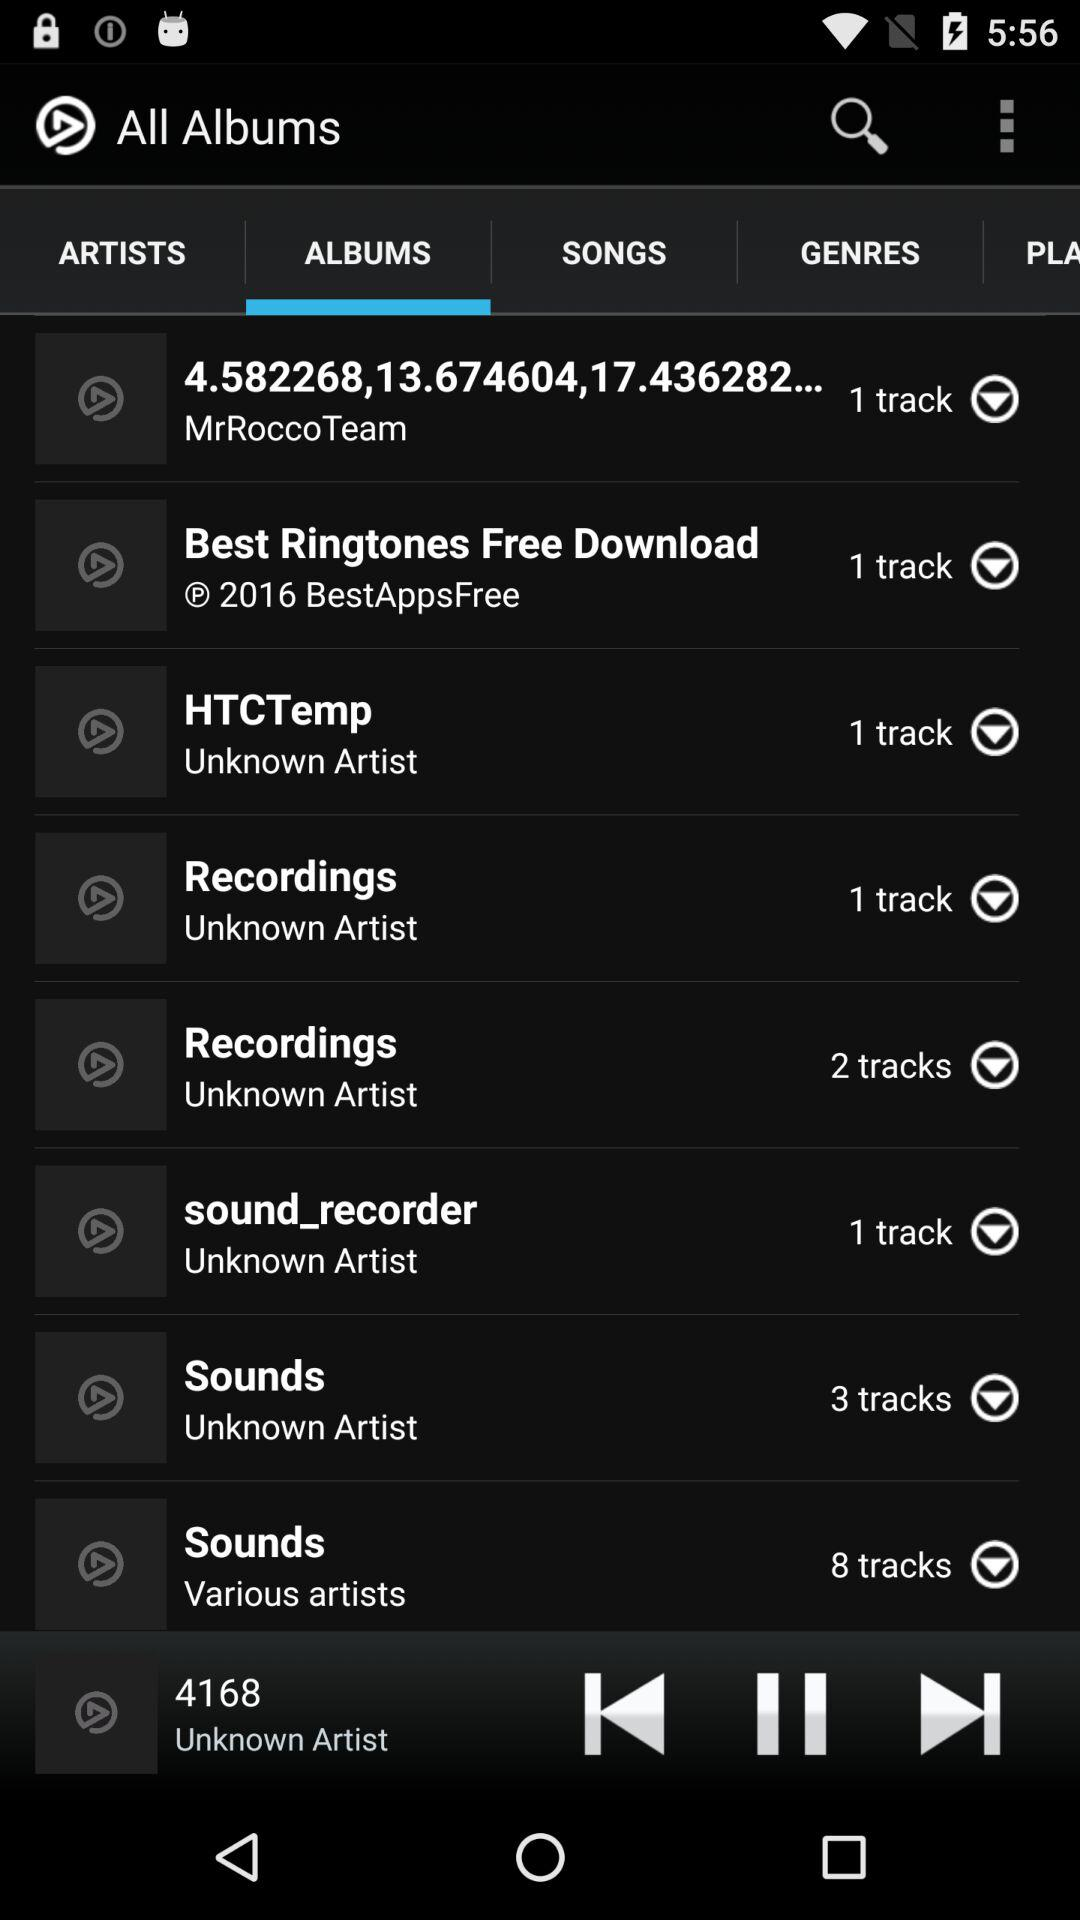How many tracks are in the MrRoccoTeam? There is 1 track. 